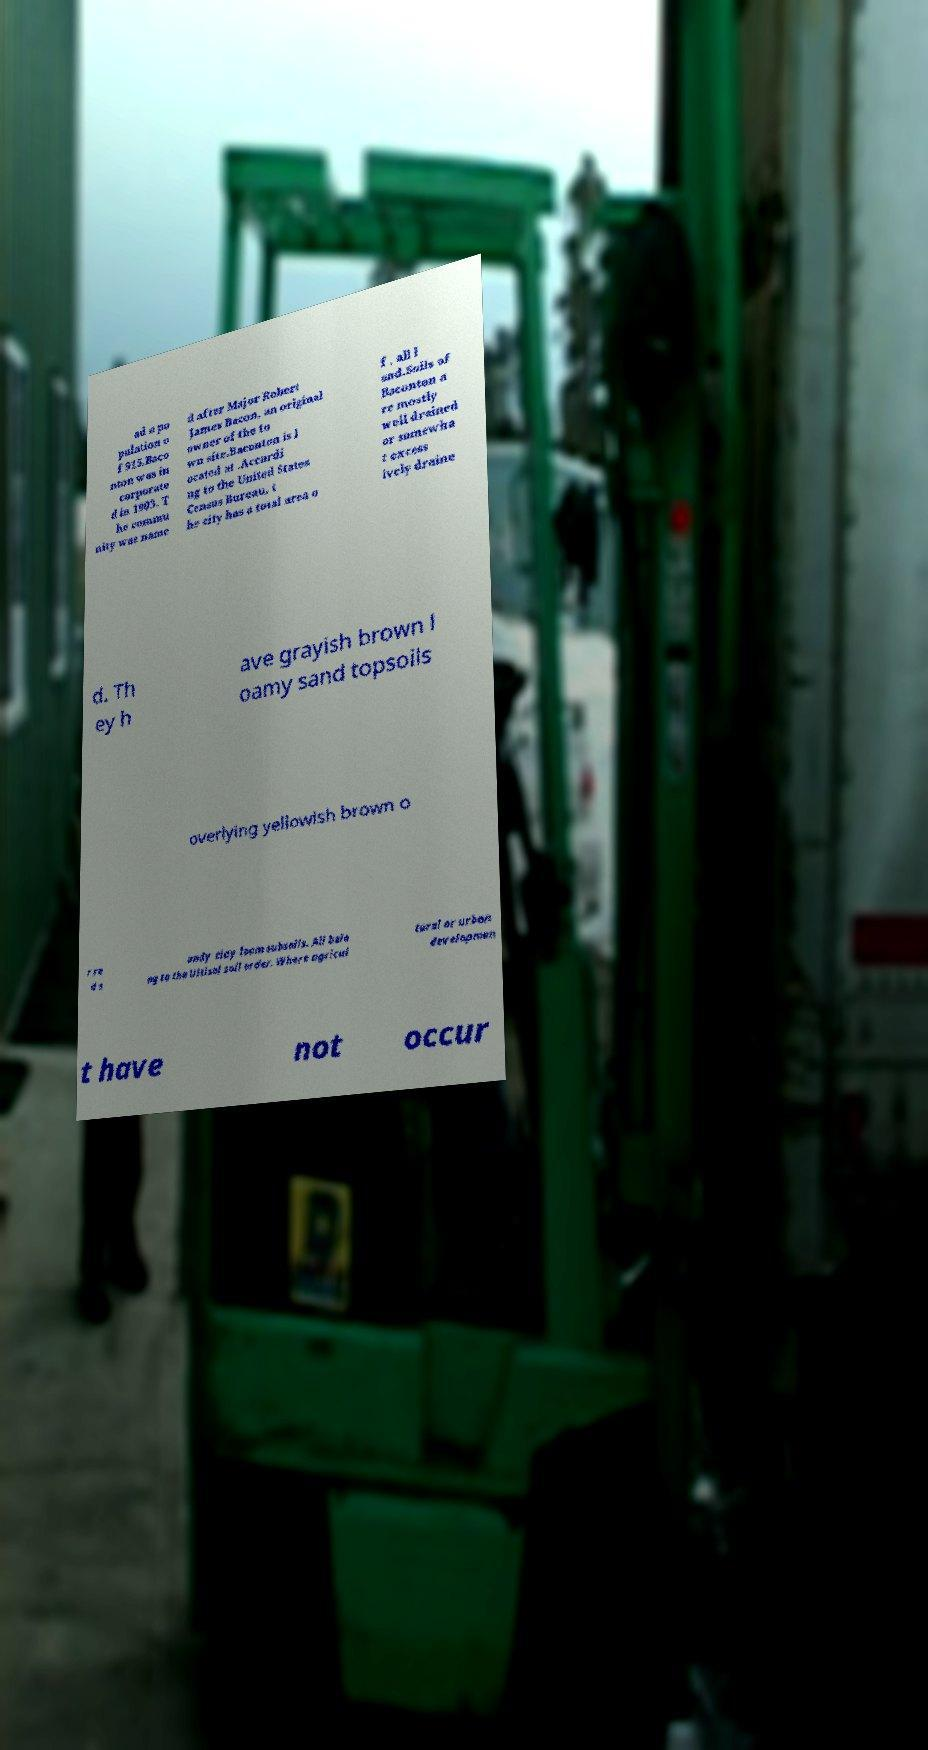What messages or text are displayed in this image? I need them in a readable, typed format. ad a po pulation o f 915.Baco nton was in corporate d in 1903. T he commu nity was name d after Major Robert James Bacon, an original owner of the to wn site.Baconton is l ocated at .Accordi ng to the United States Census Bureau, t he city has a total area o f , all l and.Soils of Baconton a re mostly well drained or somewha t excess ively draine d. Th ey h ave grayish brown l oamy sand topsoils overlying yellowish brown o r re d s andy clay loam subsoils. All belo ng to the Ultisol soil order. Where agricul tural or urban developmen t have not occur 